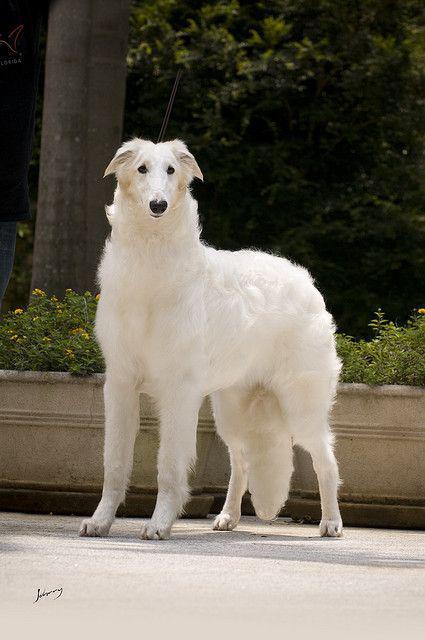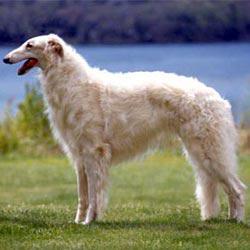The first image is the image on the left, the second image is the image on the right. Evaluate the accuracy of this statement regarding the images: "Each image shows exactly one dog standing on all fours outdoors.". Is it true? Answer yes or no. Yes. The first image is the image on the left, the second image is the image on the right. Assess this claim about the two images: "All the dogs are standing on all fours in the grass.". Correct or not? Answer yes or no. No. 